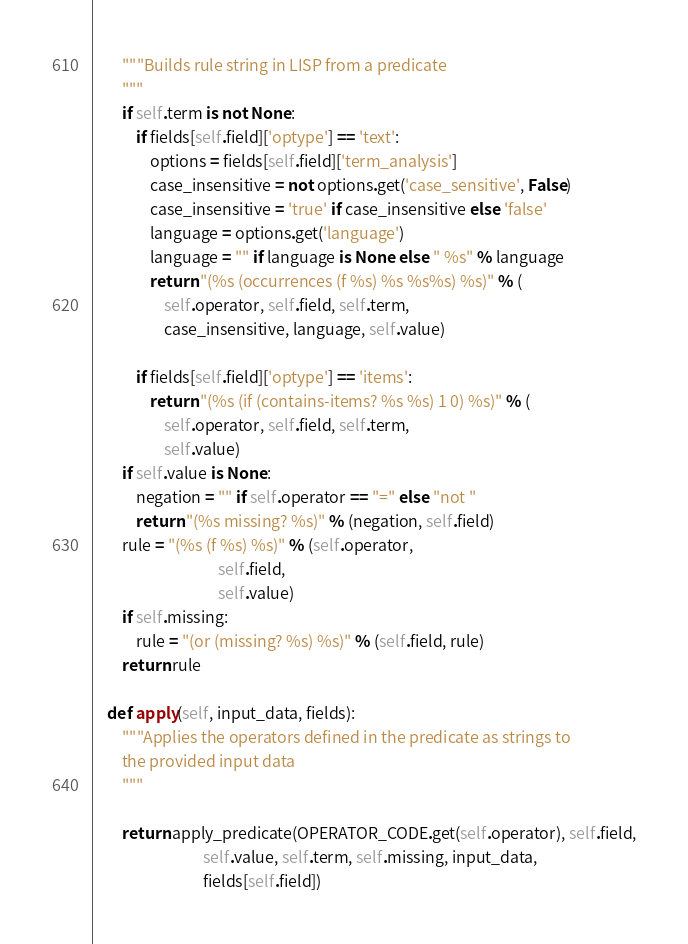<code> <loc_0><loc_0><loc_500><loc_500><_Python_>        """Builds rule string in LISP from a predicate
        """
        if self.term is not None:
            if fields[self.field]['optype'] == 'text':
                options = fields[self.field]['term_analysis']
                case_insensitive = not options.get('case_sensitive', False)
                case_insensitive = 'true' if case_insensitive else 'false'
                language = options.get('language')
                language = "" if language is None else " %s" % language
                return "(%s (occurrences (f %s) %s %s%s) %s)" % (
                    self.operator, self.field, self.term,
                    case_insensitive, language, self.value)

            if fields[self.field]['optype'] == 'items':
                return "(%s (if (contains-items? %s %s) 1 0) %s)" % (
                    self.operator, self.field, self.term,
                    self.value)
        if self.value is None:
            negation = "" if self.operator == "=" else "not "
            return "(%s missing? %s)" % (negation, self.field)
        rule = "(%s (f %s) %s)" % (self.operator,
                                   self.field,
                                   self.value)
        if self.missing:
            rule = "(or (missing? %s) %s)" % (self.field, rule)
        return rule

    def apply(self, input_data, fields):
        """Applies the operators defined in the predicate as strings to
        the provided input data
        """

        return apply_predicate(OPERATOR_CODE.get(self.operator), self.field,
                               self.value, self.term, self.missing, input_data,
                               fields[self.field])
</code> 